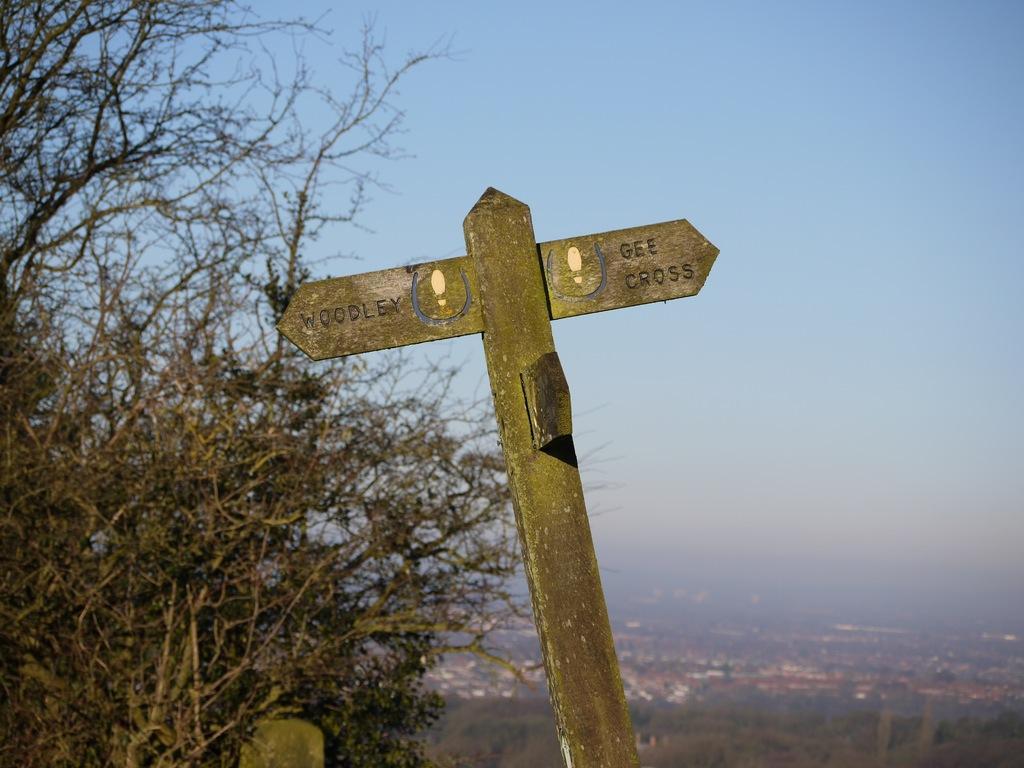Can you describe this image briefly? This picture is clicked outside. In the center there is an object on which we can see the text. On the left we can see the trees and the dry stems. In the background we can see the sky and many other objects which seems to be the buildings and there are some objects in the background. 